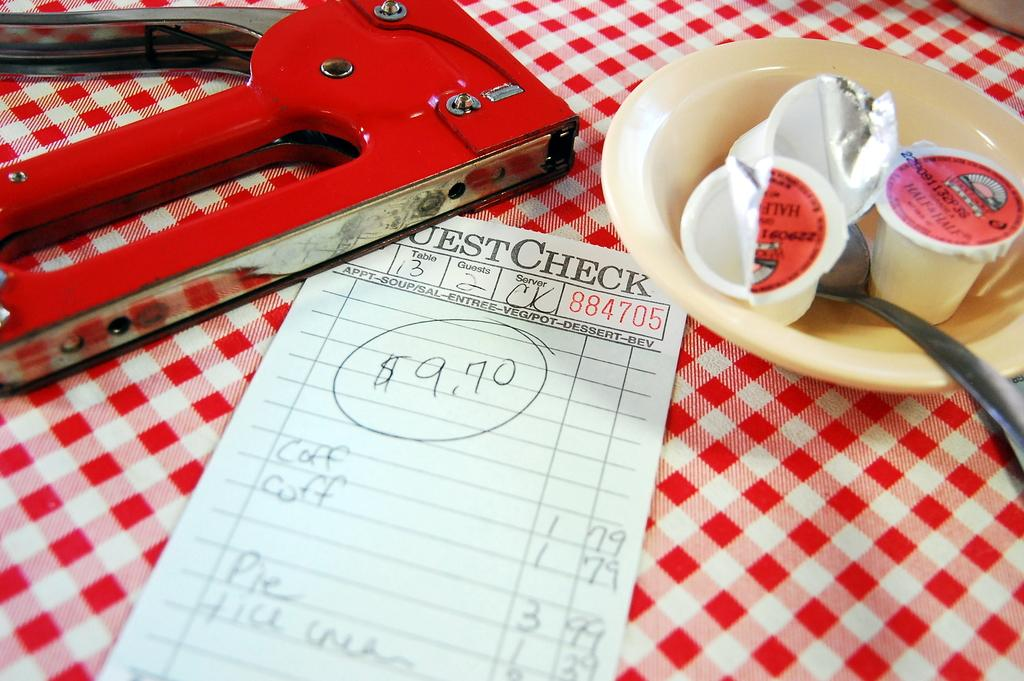<image>
Create a compact narrative representing the image presented. The guest check cost a total of 9.70 dollars 